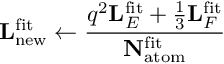<formula> <loc_0><loc_0><loc_500><loc_500>L _ { n e w } ^ { f i t } \leftarrow \frac { q ^ { 2 } L _ { E } ^ { f i t } + \frac { 1 } { 3 } L _ { F } ^ { f i t } } { N _ { a t o m } ^ { f i t } }</formula> 